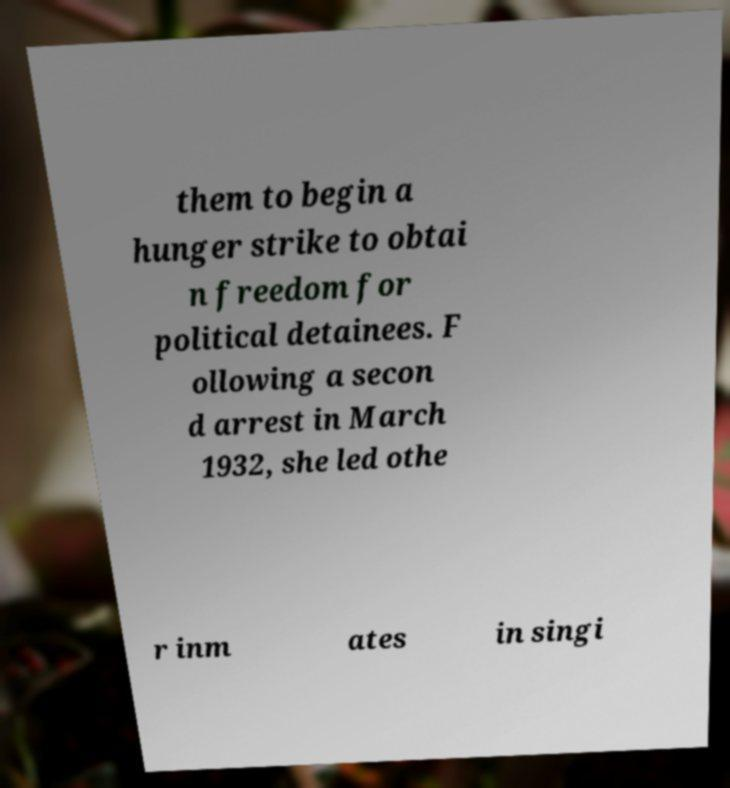Could you assist in decoding the text presented in this image and type it out clearly? them to begin a hunger strike to obtai n freedom for political detainees. F ollowing a secon d arrest in March 1932, she led othe r inm ates in singi 